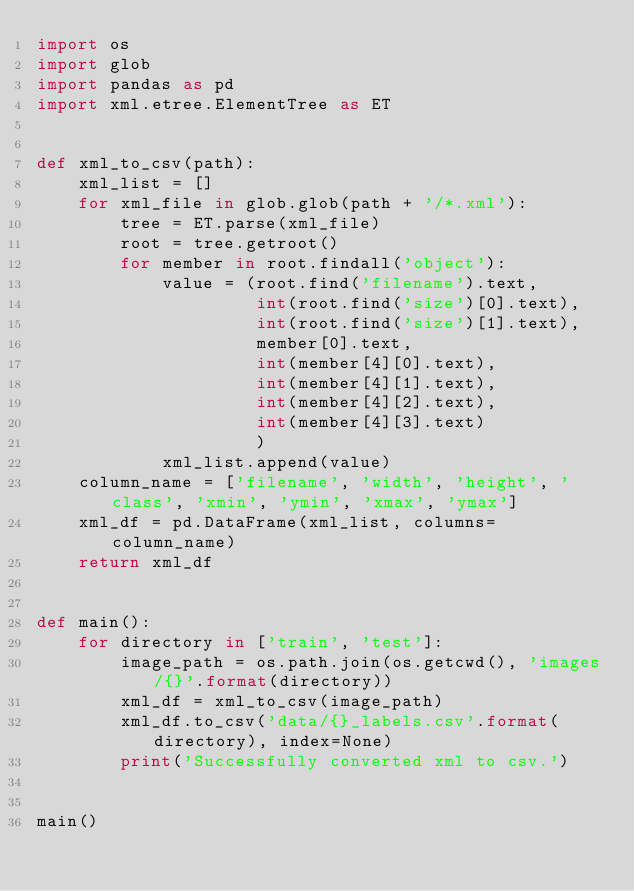<code> <loc_0><loc_0><loc_500><loc_500><_Python_>import os
import glob
import pandas as pd
import xml.etree.ElementTree as ET


def xml_to_csv(path):
    xml_list = []
    for xml_file in glob.glob(path + '/*.xml'):
        tree = ET.parse(xml_file)
        root = tree.getroot()
        for member in root.findall('object'):
            value = (root.find('filename').text,
                     int(root.find('size')[0].text),
                     int(root.find('size')[1].text),
                     member[0].text,
                     int(member[4][0].text),
                     int(member[4][1].text),
                     int(member[4][2].text),
                     int(member[4][3].text)
                     )
            xml_list.append(value)
    column_name = ['filename', 'width', 'height', 'class', 'xmin', 'ymin', 'xmax', 'ymax']
    xml_df = pd.DataFrame(xml_list, columns=column_name)
    return xml_df


def main():
    for directory in ['train', 'test']:
        image_path = os.path.join(os.getcwd(), 'images/{}'.format(directory))
        xml_df = xml_to_csv(image_path)
        xml_df.to_csv('data/{}_labels.csv'.format(directory), index=None)
        print('Successfully converted xml to csv.')


main()</code> 